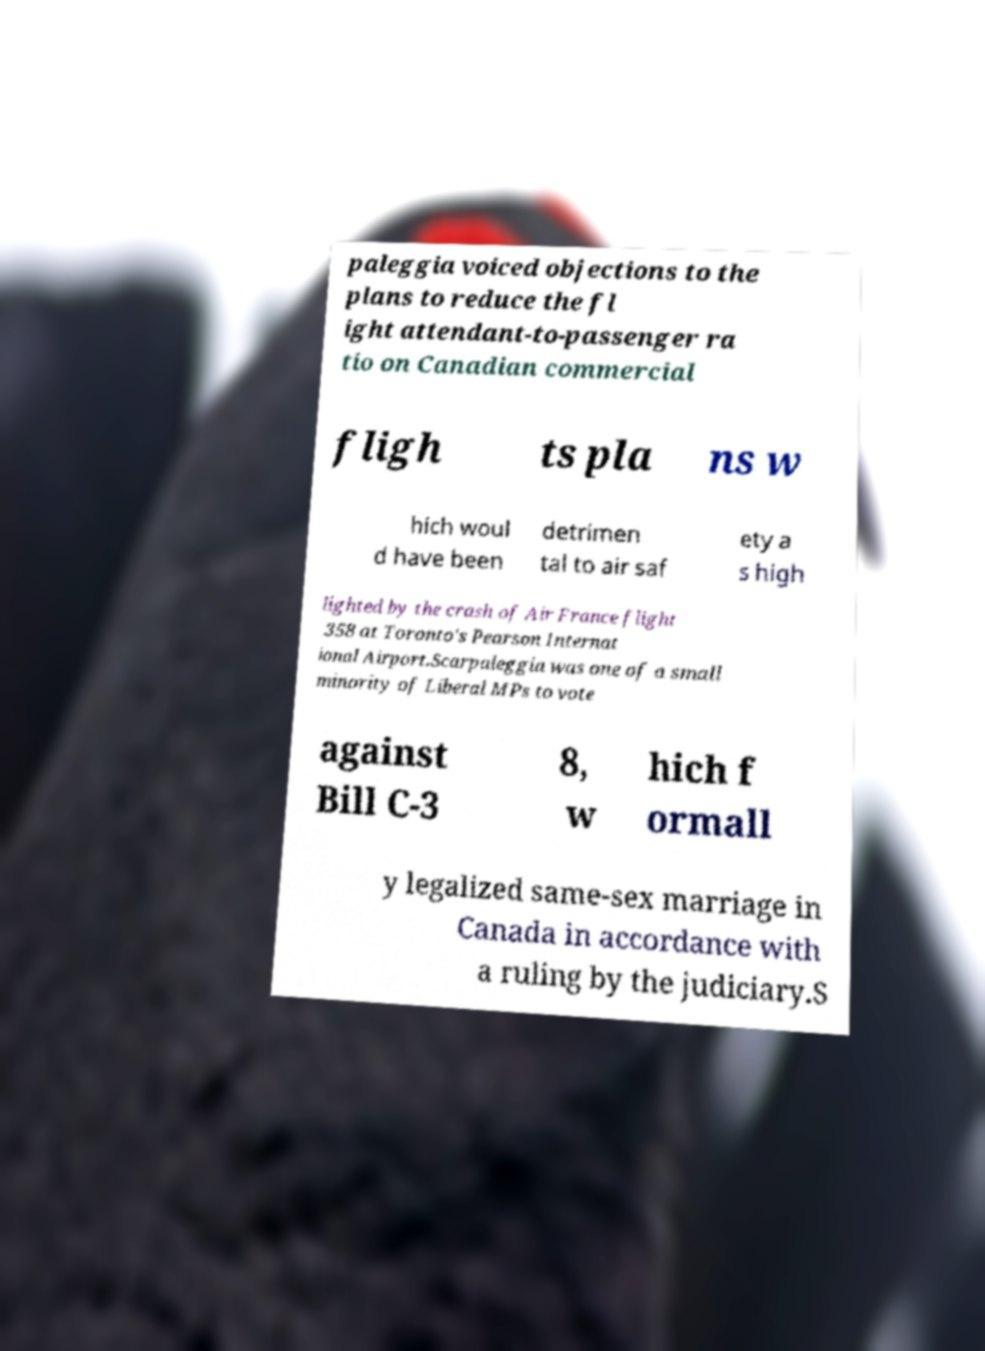There's text embedded in this image that I need extracted. Can you transcribe it verbatim? paleggia voiced objections to the plans to reduce the fl ight attendant-to-passenger ra tio on Canadian commercial fligh ts pla ns w hich woul d have been detrimen tal to air saf ety a s high lighted by the crash of Air France flight 358 at Toronto's Pearson Internat ional Airport.Scarpaleggia was one of a small minority of Liberal MPs to vote against Bill C-3 8, w hich f ormall y legalized same-sex marriage in Canada in accordance with a ruling by the judiciary.S 